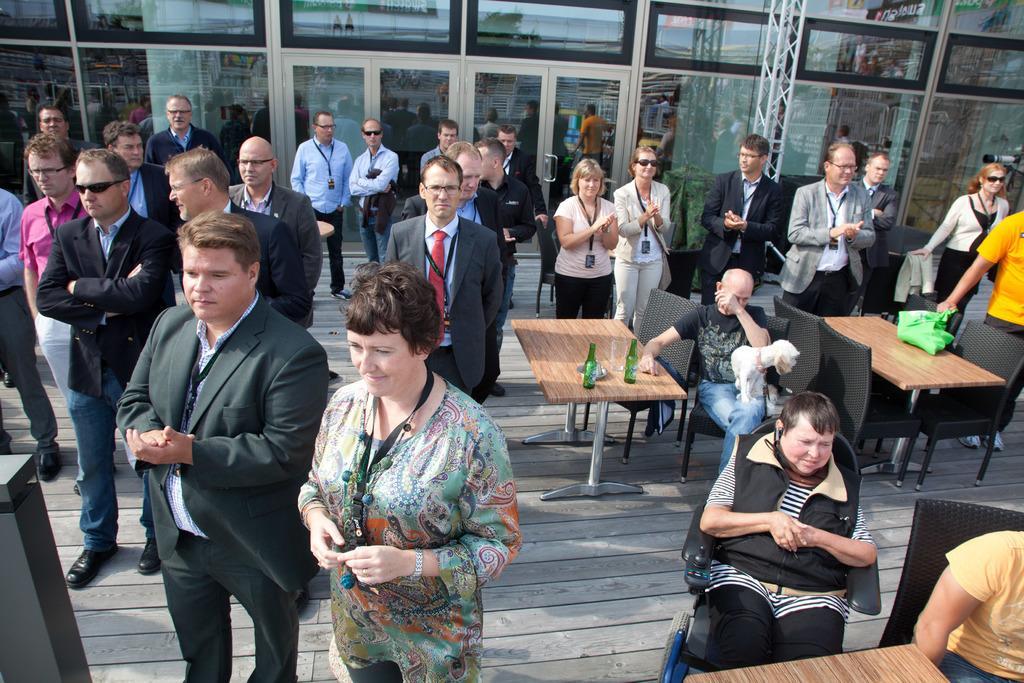How would you summarize this image in a sentence or two? In this image there are a few people standing, few are clapping and the few are sitting on the chairs, in front of them there is a table. One of the table there are bottles. In the background there is a building. 